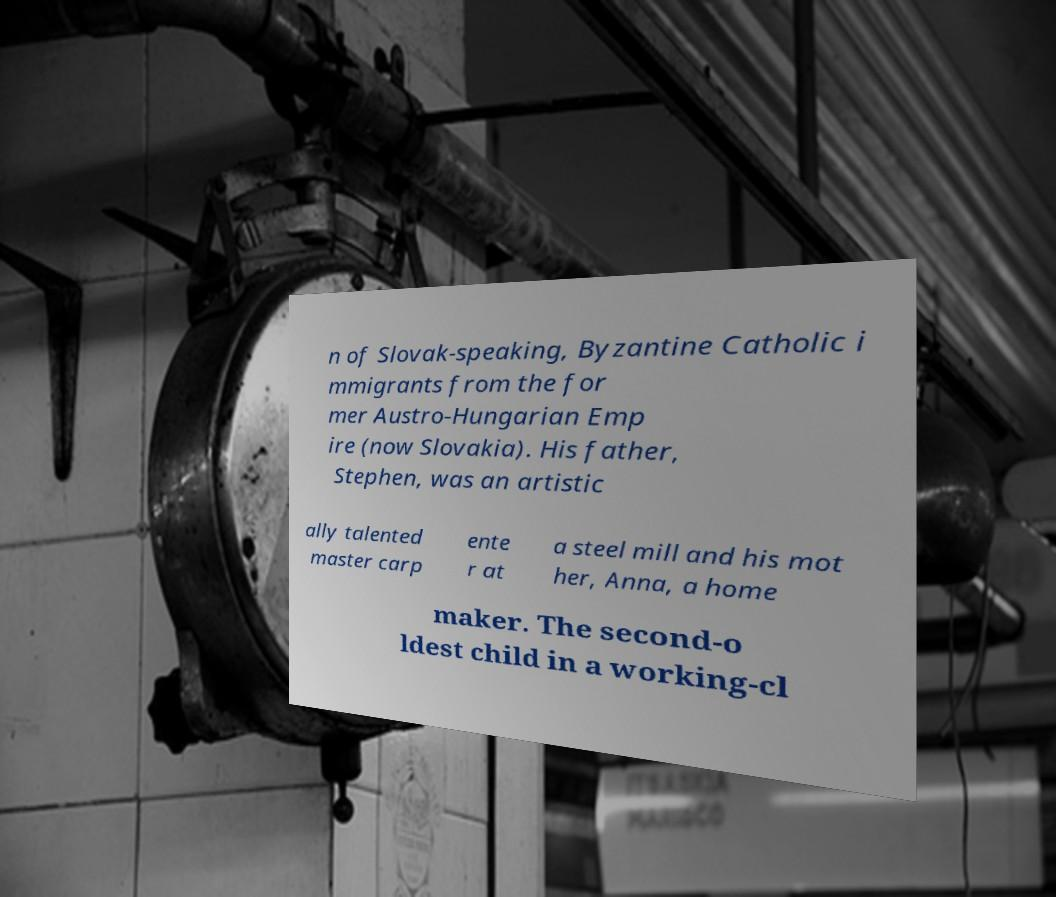For documentation purposes, I need the text within this image transcribed. Could you provide that? n of Slovak-speaking, Byzantine Catholic i mmigrants from the for mer Austro-Hungarian Emp ire (now Slovakia). His father, Stephen, was an artistic ally talented master carp ente r at a steel mill and his mot her, Anna, a home maker. The second-o ldest child in a working-cl 